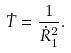<formula> <loc_0><loc_0><loc_500><loc_500>\dot { T } = \frac { 1 } { \dot { R } _ { 1 } ^ { 2 } } .</formula> 